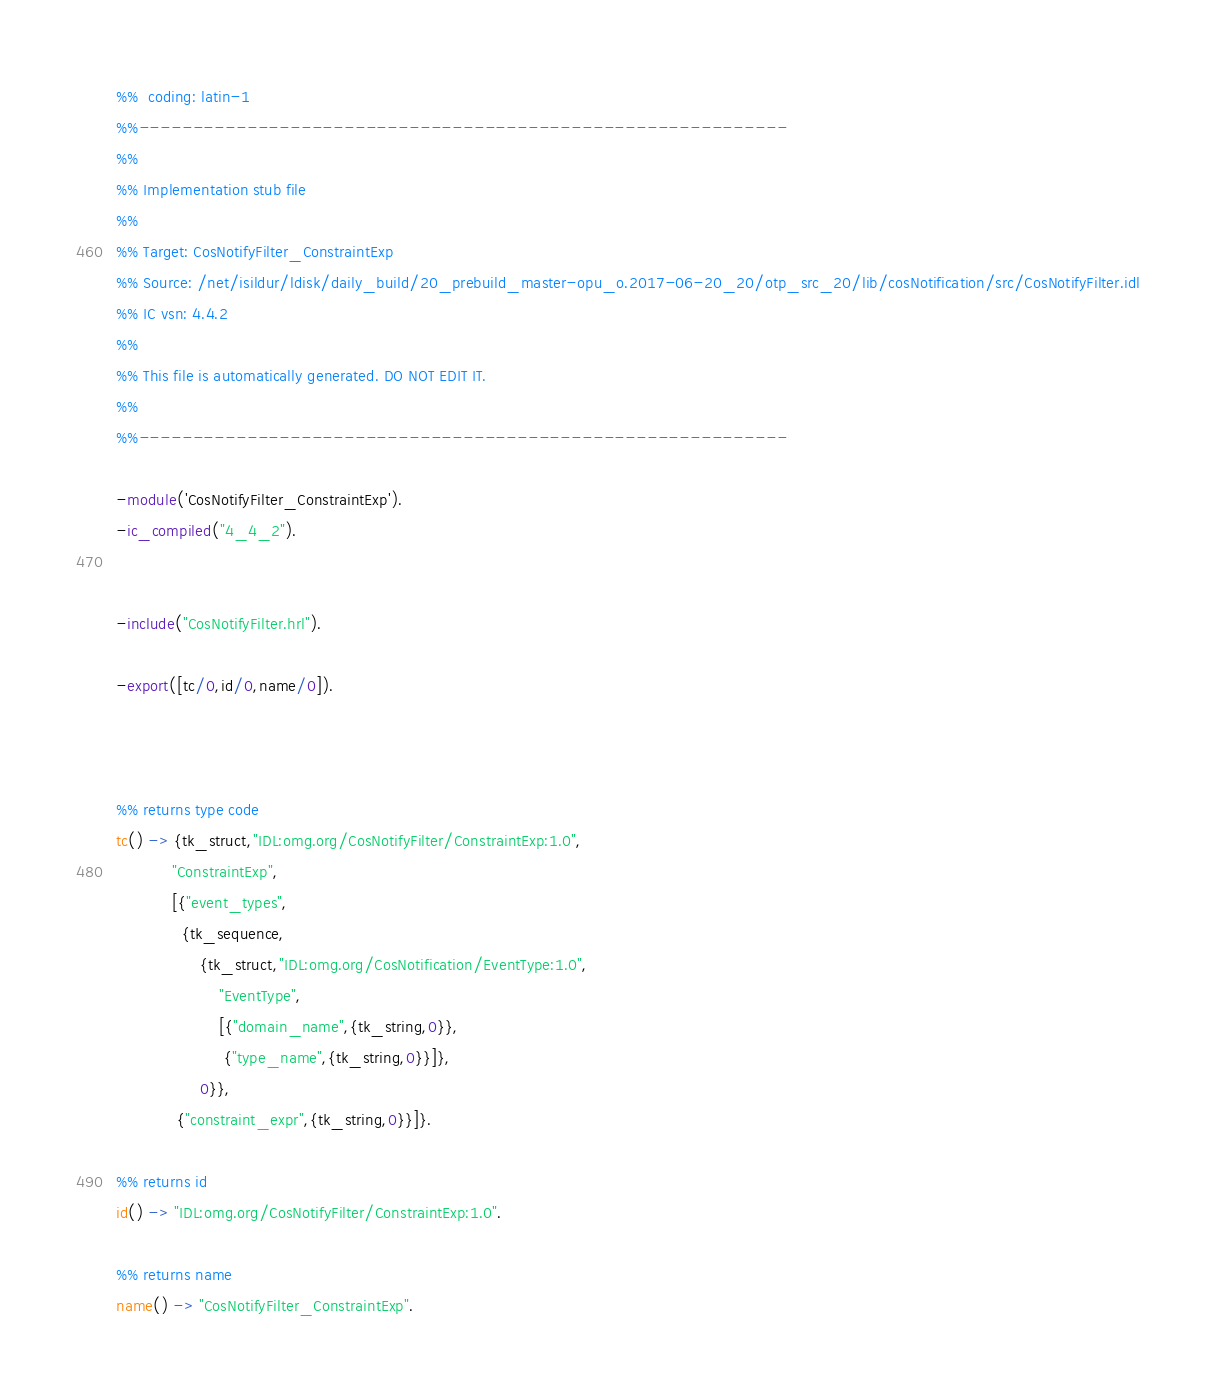<code> <loc_0><loc_0><loc_500><loc_500><_Erlang_>%%  coding: latin-1
%%------------------------------------------------------------
%%
%% Implementation stub file
%% 
%% Target: CosNotifyFilter_ConstraintExp
%% Source: /net/isildur/ldisk/daily_build/20_prebuild_master-opu_o.2017-06-20_20/otp_src_20/lib/cosNotification/src/CosNotifyFilter.idl
%% IC vsn: 4.4.2
%% 
%% This file is automatically generated. DO NOT EDIT IT.
%%
%%------------------------------------------------------------

-module('CosNotifyFilter_ConstraintExp').
-ic_compiled("4_4_2").


-include("CosNotifyFilter.hrl").

-export([tc/0,id/0,name/0]).



%% returns type code
tc() -> {tk_struct,"IDL:omg.org/CosNotifyFilter/ConstraintExp:1.0",
            "ConstraintExp",
            [{"event_types",
              {tk_sequence,
                  {tk_struct,"IDL:omg.org/CosNotification/EventType:1.0",
                      "EventType",
                      [{"domain_name",{tk_string,0}},
                       {"type_name",{tk_string,0}}]},
                  0}},
             {"constraint_expr",{tk_string,0}}]}.

%% returns id
id() -> "IDL:omg.org/CosNotifyFilter/ConstraintExp:1.0".

%% returns name
name() -> "CosNotifyFilter_ConstraintExp".



</code> 